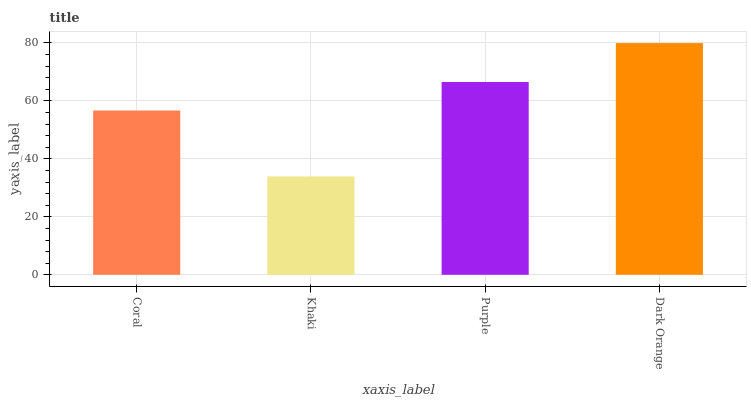Is Khaki the minimum?
Answer yes or no. Yes. Is Dark Orange the maximum?
Answer yes or no. Yes. Is Purple the minimum?
Answer yes or no. No. Is Purple the maximum?
Answer yes or no. No. Is Purple greater than Khaki?
Answer yes or no. Yes. Is Khaki less than Purple?
Answer yes or no. Yes. Is Khaki greater than Purple?
Answer yes or no. No. Is Purple less than Khaki?
Answer yes or no. No. Is Purple the high median?
Answer yes or no. Yes. Is Coral the low median?
Answer yes or no. Yes. Is Dark Orange the high median?
Answer yes or no. No. Is Dark Orange the low median?
Answer yes or no. No. 